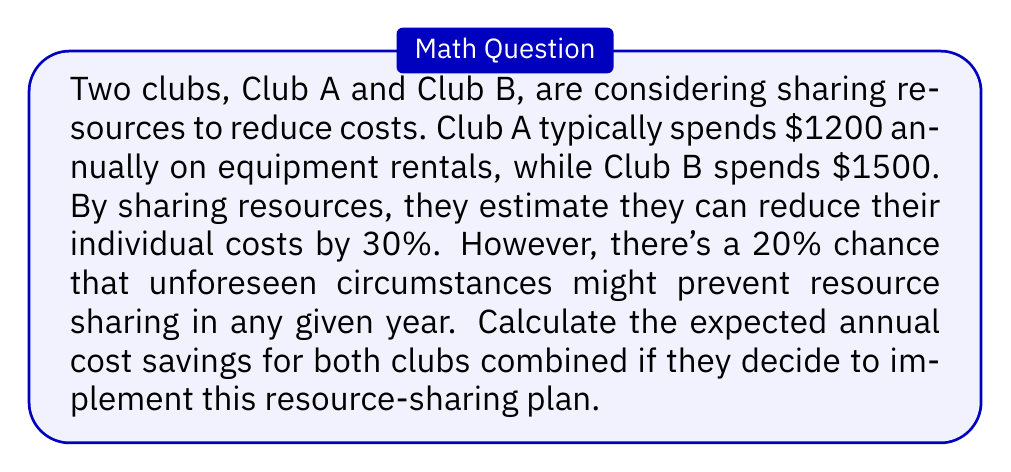Could you help me with this problem? Let's approach this step-by-step:

1) First, calculate the costs without resource sharing:
   Club A: $1200
   Club B: $1500
   Total: $1200 + $1500 = $2700

2) Calculate the reduced costs with resource sharing (70% of original):
   Club A: $1200 * 0.7 = $840
   Club B: $1500 * 0.7 = $1050
   Total with sharing: $840 + $1050 = $1890

3) Calculate the total savings if resource sharing occurs:
   $2700 - $1890 = $810

4) Now, consider the probabilities:
   - 80% chance (0.8) that resource sharing will occur
   - 20% chance (0.2) that it won't occur

5) Calculate the expected value of savings:
   $$E(\text{savings}) = 0.8 * 810 + 0.2 * 0$$
   $$E(\text{savings}) = 648 + 0 = 648$$

Therefore, the expected annual cost savings for both clubs combined is $648.
Answer: $648 